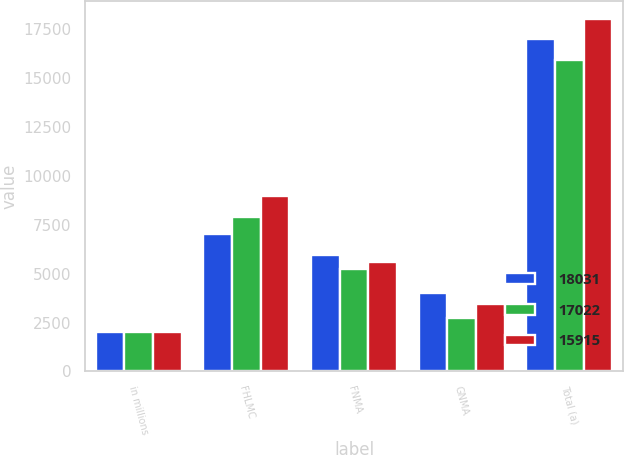Convert chart. <chart><loc_0><loc_0><loc_500><loc_500><stacked_bar_chart><ecel><fcel>in millions<fcel>FHLMC<fcel>FNMA<fcel>GNMA<fcel>Total (a)<nl><fcel>18031<fcel>2013<fcel>7047<fcel>5978<fcel>3997<fcel>17022<nl><fcel>17022<fcel>2012<fcel>7923<fcel>5246<fcel>2746<fcel>15915<nl><fcel>15915<fcel>2011<fcel>8984<fcel>5583<fcel>3464<fcel>18031<nl></chart> 